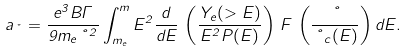<formula> <loc_0><loc_0><loc_500><loc_500>a _ { \nu } = \frac { e ^ { 3 } B \Gamma } { 9 m _ { e } \nu ^ { 2 } } \int _ { m _ { e } } ^ { m } E ^ { 2 } \frac { d } { d E } \, \left ( \frac { Y _ { e } ( > E ) } { E ^ { 2 } P ( E ) } \right ) \, F \, \left ( \frac { \nu } { \nu _ { c } ( E ) } \right ) d E .</formula> 